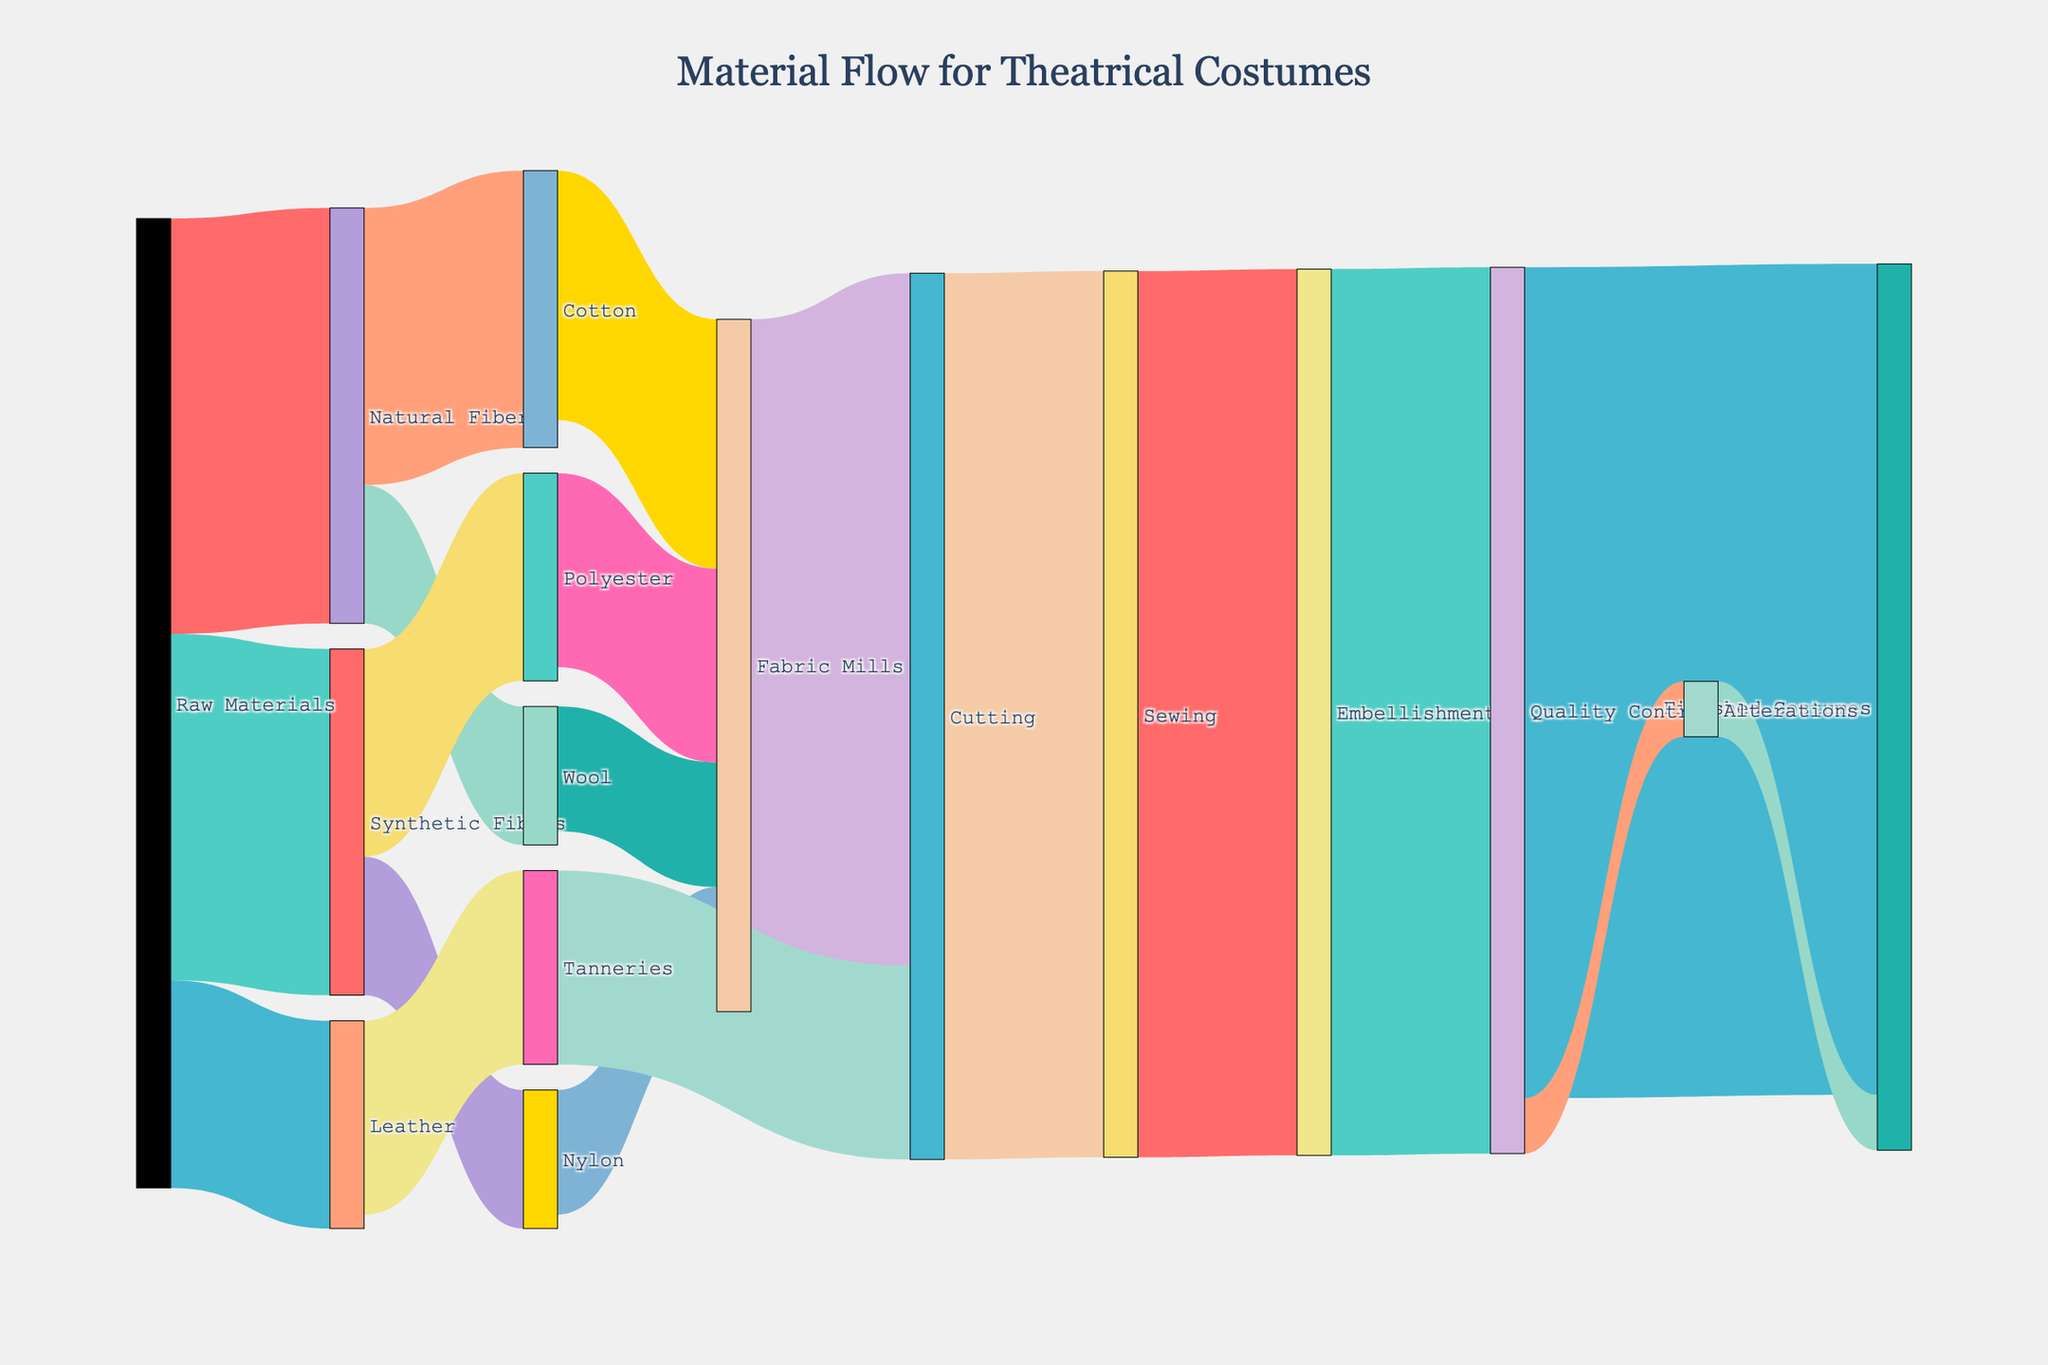How many different raw materials are there in the diagram? Identify the different raw materials from the figure which are the initial nodes leading to subsequent steps.
Answer: 3 Which material has the highest flow into fabric mills? Identify the materials flowing into fabric mills and compare their values to determine the highest. Cotton contributes 18, Wool 9, Polyester 14, and Nylon 9. Cotton is the highest.
Answer: Cotton What is the total amount of material that flows into the sewing phase? Sum the values of flows going into the sewing phase. Cutting phase contributes 64 units to sewing.
Answer: 64 Does any material go into alterations from quality control? Check the links originating from quality control and their destinations. Quality control flows 4 units into alterations.
Answer: Yes What is the total amount of natural fibers used? Sum the values from raw materials to natural fibers and then to individual types. 30 units go from raw materials to natural fibers, broken into 20 (Cotton) and 10 (Wool) thereafter.
Answer: 30 Which phase has the highest output in the entire process? Identify and compare the output values for each phase. The sewing, embellishment, and quality control phases each pass on 64 units, which is the highest.
Answer: Sewing, Embellishment, Quality Control What is the difference in material flow between raw materials to natural fibers and raw materials to synthetic fibers? Subtract the value flowing to synthetic fibers from that flowing to natural fibers: 30 (Natural) - 25 (Synthetic).
Answer: 5 How many distinct endpoints are there for finished costumes? Examine the final nodes where all flows converge. There is only one distinct endpoint, which is "Finished Costumes".
Answer: 1 Which phase has the smallest contribution to the finished costumes directly? Identify the direct links to finished costumes and compare their values. Alterations contribute 4 while quality control contributes 60. The smallest is from alterations.
Answer: Alterations What is the total contribution of synthetic fibers to fabric mills? Sum the values flowing from synthetic fibers to fabric mills: Polyester contributes 14 and Nylon 9, totaling 23.
Answer: 23 